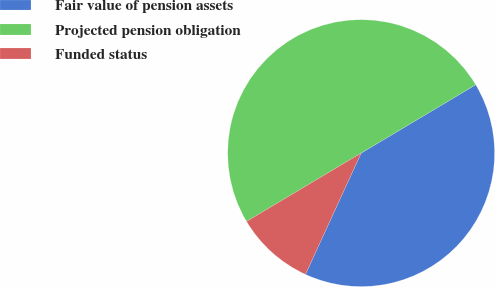Convert chart to OTSL. <chart><loc_0><loc_0><loc_500><loc_500><pie_chart><fcel>Fair value of pension assets<fcel>Projected pension obligation<fcel>Funded status<nl><fcel>40.41%<fcel>50.0%<fcel>9.59%<nl></chart> 